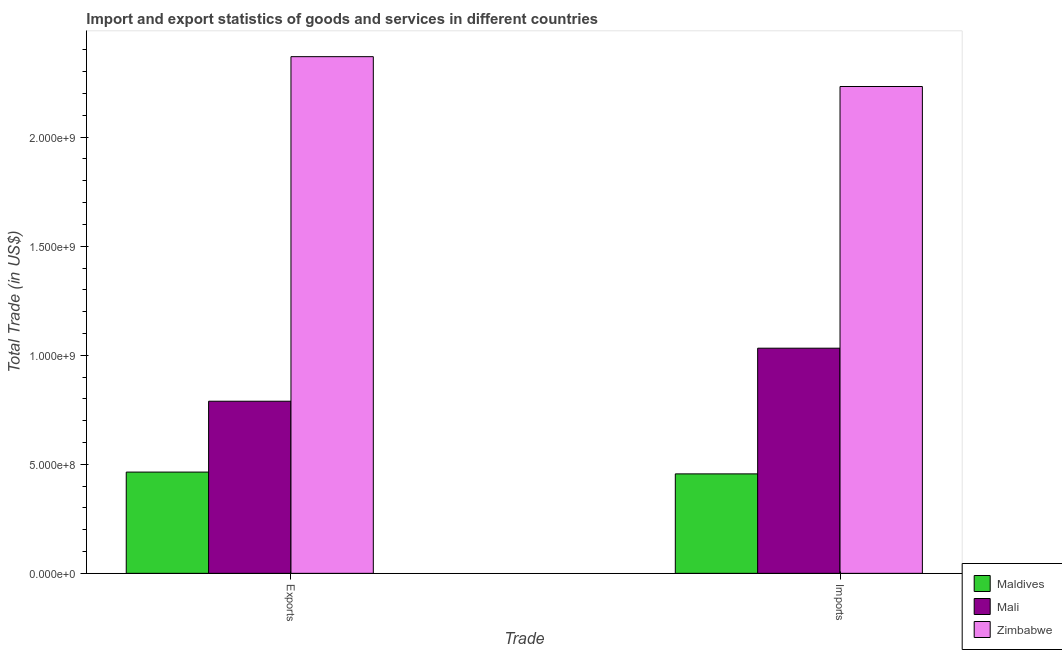Are the number of bars per tick equal to the number of legend labels?
Keep it short and to the point. Yes. Are the number of bars on each tick of the X-axis equal?
Provide a succinct answer. Yes. How many bars are there on the 1st tick from the left?
Offer a terse response. 3. What is the label of the 2nd group of bars from the left?
Your answer should be compact. Imports. What is the imports of goods and services in Maldives?
Make the answer very short. 4.56e+08. Across all countries, what is the maximum imports of goods and services?
Your answer should be compact. 2.23e+09. Across all countries, what is the minimum imports of goods and services?
Your answer should be compact. 4.56e+08. In which country was the export of goods and services maximum?
Offer a terse response. Zimbabwe. In which country was the imports of goods and services minimum?
Offer a terse response. Maldives. What is the total imports of goods and services in the graph?
Make the answer very short. 3.72e+09. What is the difference between the imports of goods and services in Maldives and that in Zimbabwe?
Ensure brevity in your answer.  -1.78e+09. What is the difference between the imports of goods and services in Maldives and the export of goods and services in Zimbabwe?
Your answer should be compact. -1.91e+09. What is the average export of goods and services per country?
Provide a succinct answer. 1.21e+09. What is the difference between the export of goods and services and imports of goods and services in Zimbabwe?
Ensure brevity in your answer.  1.37e+08. In how many countries, is the imports of goods and services greater than 1400000000 US$?
Keep it short and to the point. 1. What is the ratio of the imports of goods and services in Mali to that in Zimbabwe?
Provide a succinct answer. 0.46. What does the 3rd bar from the left in Imports represents?
Make the answer very short. Zimbabwe. What does the 3rd bar from the right in Exports represents?
Provide a short and direct response. Maldives. Are all the bars in the graph horizontal?
Give a very brief answer. No. What is the difference between two consecutive major ticks on the Y-axis?
Your answer should be compact. 5.00e+08. Does the graph contain any zero values?
Offer a terse response. No. How are the legend labels stacked?
Your answer should be very brief. Vertical. What is the title of the graph?
Offer a terse response. Import and export statistics of goods and services in different countries. What is the label or title of the X-axis?
Ensure brevity in your answer.  Trade. What is the label or title of the Y-axis?
Your answer should be very brief. Total Trade (in US$). What is the Total Trade (in US$) of Maldives in Exports?
Offer a terse response. 4.64e+08. What is the Total Trade (in US$) of Mali in Exports?
Provide a succinct answer. 7.89e+08. What is the Total Trade (in US$) of Zimbabwe in Exports?
Give a very brief answer. 2.37e+09. What is the Total Trade (in US$) in Maldives in Imports?
Offer a very short reply. 4.56e+08. What is the Total Trade (in US$) in Mali in Imports?
Your answer should be compact. 1.03e+09. What is the Total Trade (in US$) in Zimbabwe in Imports?
Provide a short and direct response. 2.23e+09. Across all Trade, what is the maximum Total Trade (in US$) of Maldives?
Provide a short and direct response. 4.64e+08. Across all Trade, what is the maximum Total Trade (in US$) of Mali?
Your answer should be very brief. 1.03e+09. Across all Trade, what is the maximum Total Trade (in US$) in Zimbabwe?
Your answer should be compact. 2.37e+09. Across all Trade, what is the minimum Total Trade (in US$) of Maldives?
Offer a very short reply. 4.56e+08. Across all Trade, what is the minimum Total Trade (in US$) of Mali?
Your answer should be very brief. 7.89e+08. Across all Trade, what is the minimum Total Trade (in US$) in Zimbabwe?
Give a very brief answer. 2.23e+09. What is the total Total Trade (in US$) of Maldives in the graph?
Provide a short and direct response. 9.20e+08. What is the total Total Trade (in US$) in Mali in the graph?
Make the answer very short. 1.82e+09. What is the total Total Trade (in US$) of Zimbabwe in the graph?
Your response must be concise. 4.60e+09. What is the difference between the Total Trade (in US$) in Maldives in Exports and that in Imports?
Ensure brevity in your answer.  8.25e+06. What is the difference between the Total Trade (in US$) of Mali in Exports and that in Imports?
Make the answer very short. -2.43e+08. What is the difference between the Total Trade (in US$) of Zimbabwe in Exports and that in Imports?
Provide a short and direct response. 1.37e+08. What is the difference between the Total Trade (in US$) of Maldives in Exports and the Total Trade (in US$) of Mali in Imports?
Your answer should be very brief. -5.68e+08. What is the difference between the Total Trade (in US$) in Maldives in Exports and the Total Trade (in US$) in Zimbabwe in Imports?
Your answer should be compact. -1.77e+09. What is the difference between the Total Trade (in US$) in Mali in Exports and the Total Trade (in US$) in Zimbabwe in Imports?
Keep it short and to the point. -1.44e+09. What is the average Total Trade (in US$) of Maldives per Trade?
Provide a succinct answer. 4.60e+08. What is the average Total Trade (in US$) of Mali per Trade?
Your response must be concise. 9.11e+08. What is the average Total Trade (in US$) in Zimbabwe per Trade?
Offer a very short reply. 2.30e+09. What is the difference between the Total Trade (in US$) of Maldives and Total Trade (in US$) of Mali in Exports?
Your answer should be very brief. -3.25e+08. What is the difference between the Total Trade (in US$) of Maldives and Total Trade (in US$) of Zimbabwe in Exports?
Your response must be concise. -1.90e+09. What is the difference between the Total Trade (in US$) in Mali and Total Trade (in US$) in Zimbabwe in Exports?
Keep it short and to the point. -1.58e+09. What is the difference between the Total Trade (in US$) in Maldives and Total Trade (in US$) in Mali in Imports?
Offer a very short reply. -5.76e+08. What is the difference between the Total Trade (in US$) of Maldives and Total Trade (in US$) of Zimbabwe in Imports?
Provide a short and direct response. -1.78e+09. What is the difference between the Total Trade (in US$) of Mali and Total Trade (in US$) of Zimbabwe in Imports?
Ensure brevity in your answer.  -1.20e+09. What is the ratio of the Total Trade (in US$) in Maldives in Exports to that in Imports?
Make the answer very short. 1.02. What is the ratio of the Total Trade (in US$) in Mali in Exports to that in Imports?
Offer a terse response. 0.76. What is the ratio of the Total Trade (in US$) of Zimbabwe in Exports to that in Imports?
Keep it short and to the point. 1.06. What is the difference between the highest and the second highest Total Trade (in US$) of Maldives?
Your response must be concise. 8.25e+06. What is the difference between the highest and the second highest Total Trade (in US$) of Mali?
Give a very brief answer. 2.43e+08. What is the difference between the highest and the second highest Total Trade (in US$) of Zimbabwe?
Offer a terse response. 1.37e+08. What is the difference between the highest and the lowest Total Trade (in US$) in Maldives?
Your response must be concise. 8.25e+06. What is the difference between the highest and the lowest Total Trade (in US$) in Mali?
Provide a succinct answer. 2.43e+08. What is the difference between the highest and the lowest Total Trade (in US$) of Zimbabwe?
Make the answer very short. 1.37e+08. 